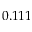Convert formula to latex. <formula><loc_0><loc_0><loc_500><loc_500>0 . 1 1 1</formula> 